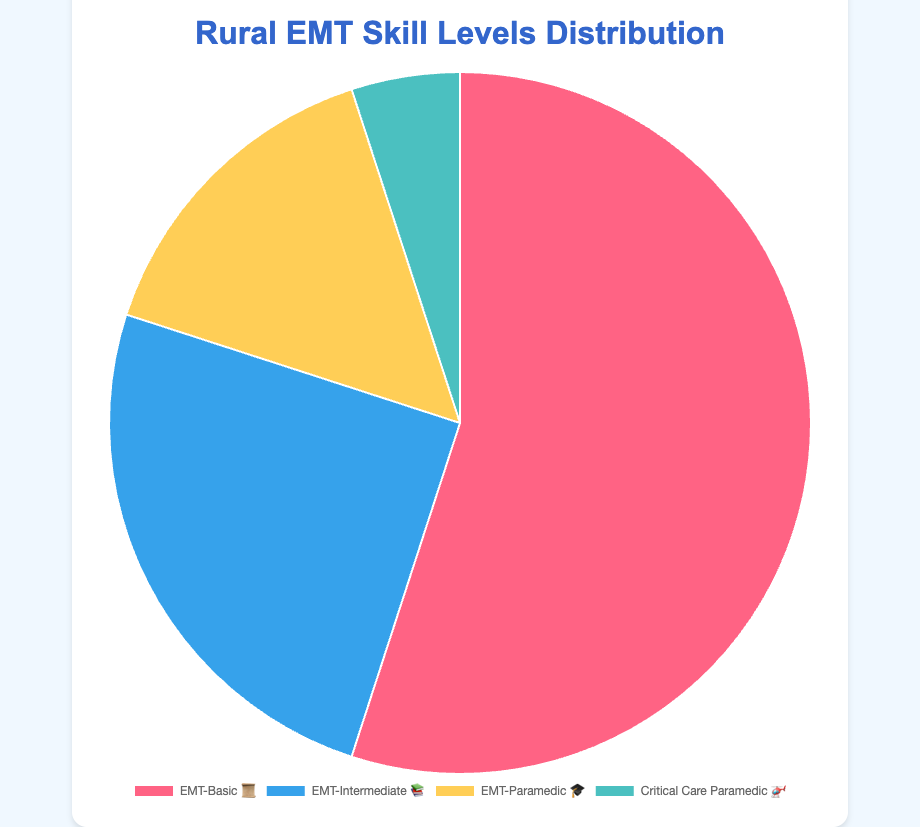Which EMI skill level has the highest percentage? The pie chart shows different certification levels with emojis: EMT-Basic 📜 has the largest segment.
Answer: EMT-Basic 📜 What percentage of EMTs are certified as Critical Care Paramedic? The chart shows Critical Care Paramedic 🚁 has a segment labeled with 5%.
Answer: 5% How do the percentages of EMT-Intermediate 📚 and EMT-Paramedic 🎓 compare? EMT-Intermediate 📚 accounts for 25%, while EMT-Paramedic 🎓 accounts for 15%. This means EMT-Intermediate has a higher percentage.
Answer: EMT-Intermediate 📚 What is the total percentage of EMTs with Basic 📜 and Intermediate 📚 certifications? Add the percentages: 55% (EMT-Basic) + 25% (EMT-Intermediate) = 80%.
Answer: 80% Which certification level has the smallest representation and what is its percentage? The chart shows Critical Care Paramedic 🚁 with the smallest segment, labeled as 5%.
Answer: Critical Care Paramedic 🚁 (5%) What is the difference in percentage between EMT-Basic 📜 and the sum of EMT-Intermediate 📚 and Critical Care Paramedic 🚁? Sum the percentages for EMT-Intermediate and Critical Care Paramedic: 25% + 5% = 30%. Difference: 55% (EMT-Basic) - 30% = 25%.
Answer: 25% What percentage of EMTs are certified as either Paramedic 🎓 or Critical Care Paramedic 🚁? Add the percentages: 15% (EMT-Paramedic) + 5% (Critical Care Paramedic) = 20%.
Answer: 20% Is the representation of EMT-Basic 📜 more than double that of EMT-Intermediate 📚? EMT-Basic 📜 has 55%, and EMT-Intermediate 📚 has 25%. Double EMT-Intermediate is 50%, which is less than 55%.
Answer: Yes What is the total percentage of EMTs who are certified above Intermediate 📚 level? EMT-Paramedic 🎓 with 15% + Critical Care Paramedic 🚁 with 5% = 20%.
Answer: 20% If the chart segments for EMT-Basic 📜 and EMT-Intermediate 📚 are combined, how do they compare with the combined segments of EMT-Paramedic 🎓 and Critical Care Paramedic 🚁? EMT-Basic 📜 (55%) + EMT-Intermediate 📚 (25%) = 80%. EMT-Paramedic 🎓 (15%) + Critical Care Paramedic 🚁 (5%) = 20%. 80% is greater than 20%.
Answer: EMT-Basic 📜 and EMT-Intermediate 📚 combined ?> EMT-Paramedic 🎓 and Critical Care Paramedic 🚁 combined 